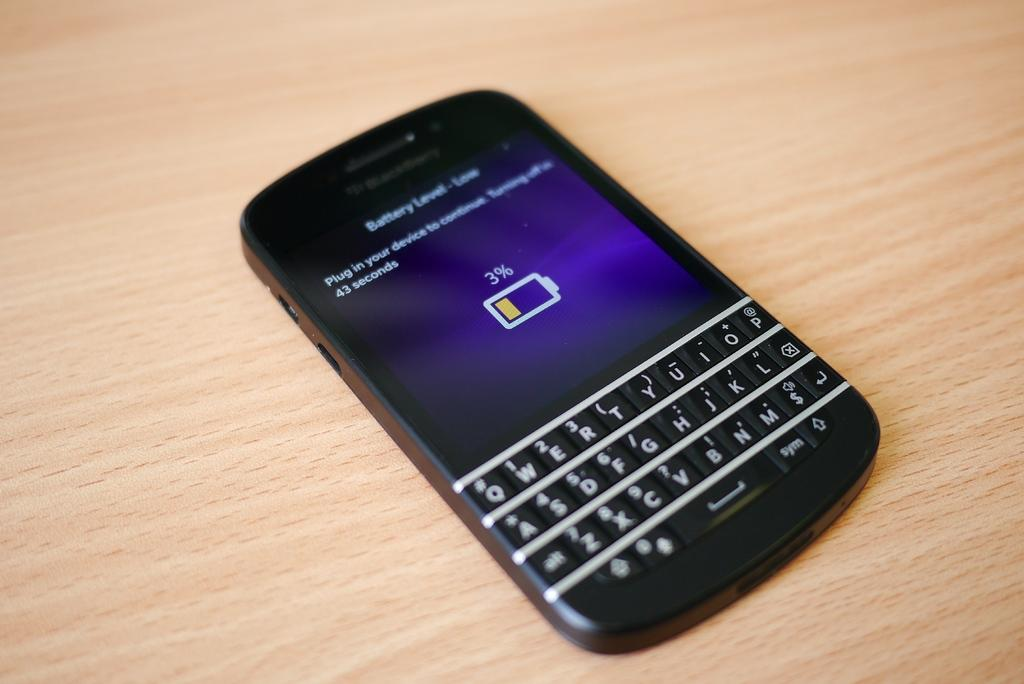<image>
Render a clear and concise summary of the photo. A phone is showing that the battery is low at 3% and will turn off in 43 seconds. 